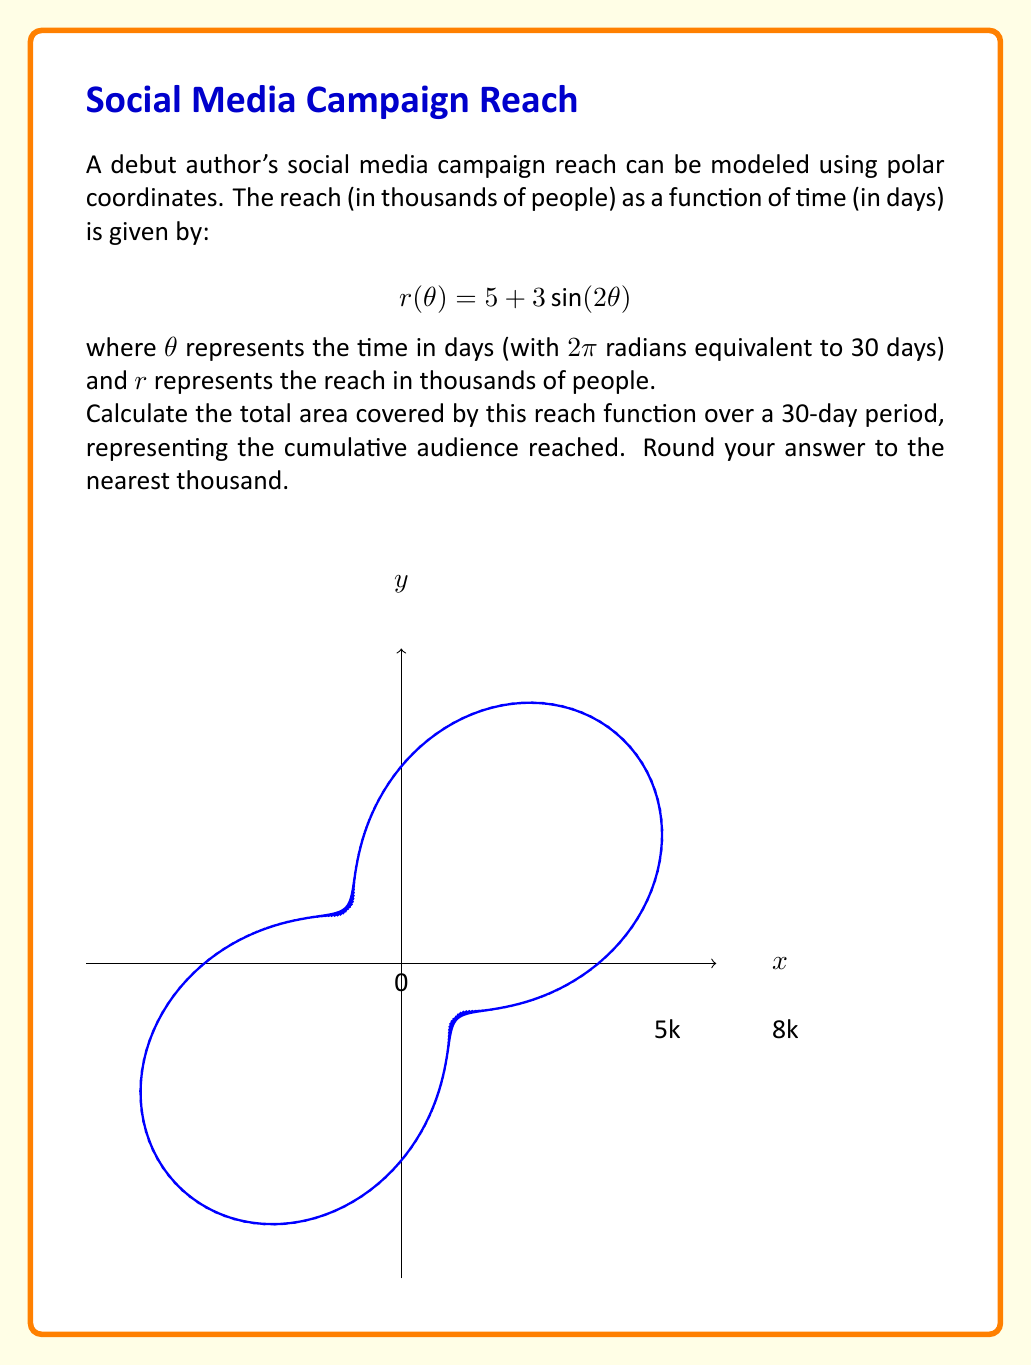Teach me how to tackle this problem. To solve this problem, we need to use the formula for the area in polar coordinates and integrate over the full period:

1) The formula for area in polar coordinates is:

   $$A = \frac{1}{2} \int_{0}^{2\pi} [r(\theta)]^2 d\theta$$

2) Substitute our function into this formula:

   $$A = \frac{1}{2} \int_{0}^{2\pi} [5 + 3\sin(2\theta)]^2 d\theta$$

3) Expand the squared term:

   $$A = \frac{1}{2} \int_{0}^{2\pi} [25 + 30\sin(2\theta) + 9\sin^2(2\theta)] d\theta$$

4) Integrate each term:
   
   $$A = \frac{1}{2} [25\theta - 15\cos(2\theta) + \frac{9}{4}\theta - \frac{9}{8}\sin(4\theta)]_{0}^{2\pi}$$

5) Evaluate at the limits:

   $$A = \frac{1}{2} [(25 \cdot 2\pi + \frac{9}{4} \cdot 2\pi) - (0 + 0)] = \frac{1}{2} \cdot 2\pi \cdot \frac{109}{4} = \frac{109\pi}{4}$$

6) This result is in square units of our original r, which was in thousands. So this represents thousands of people squared.

7) To get the actual number of people, we need to multiply by 1000:

   $$\text{Total reach} = \frac{109\pi}{4} \cdot 1000 \approx 85,530$$

8) Rounding to the nearest thousand:

   $$\text{Total reach} \approx 86,000$$
Answer: 86,000 people 